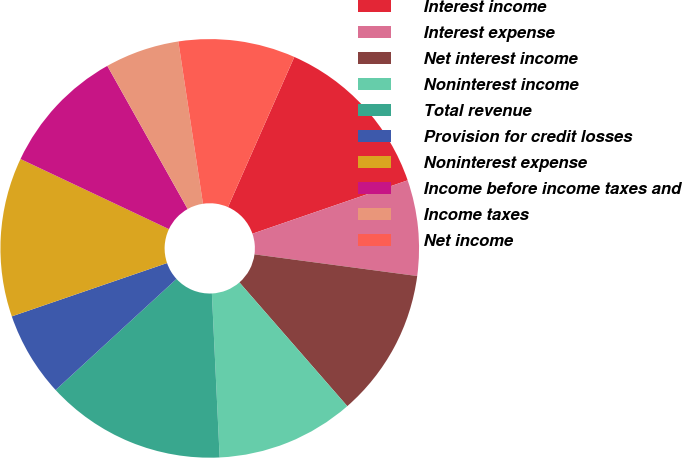<chart> <loc_0><loc_0><loc_500><loc_500><pie_chart><fcel>Interest income<fcel>Interest expense<fcel>Net interest income<fcel>Noninterest income<fcel>Total revenue<fcel>Provision for credit losses<fcel>Noninterest expense<fcel>Income before income taxes and<fcel>Income taxes<fcel>Net income<nl><fcel>13.11%<fcel>7.38%<fcel>11.48%<fcel>10.66%<fcel>13.93%<fcel>6.56%<fcel>12.29%<fcel>9.84%<fcel>5.74%<fcel>9.02%<nl></chart> 